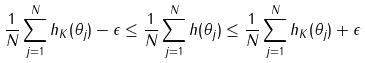Convert formula to latex. <formula><loc_0><loc_0><loc_500><loc_500>\frac { 1 } { N } \sum _ { j = 1 } ^ { N } h _ { K } ( \theta _ { j } ) - \epsilon \leq \frac { 1 } { N } \sum _ { j = 1 } ^ { N } h ( \theta _ { j } ) \leq \frac { 1 } { N } \sum _ { j = 1 } ^ { N } h _ { K } ( \theta _ { j } ) + \epsilon</formula> 